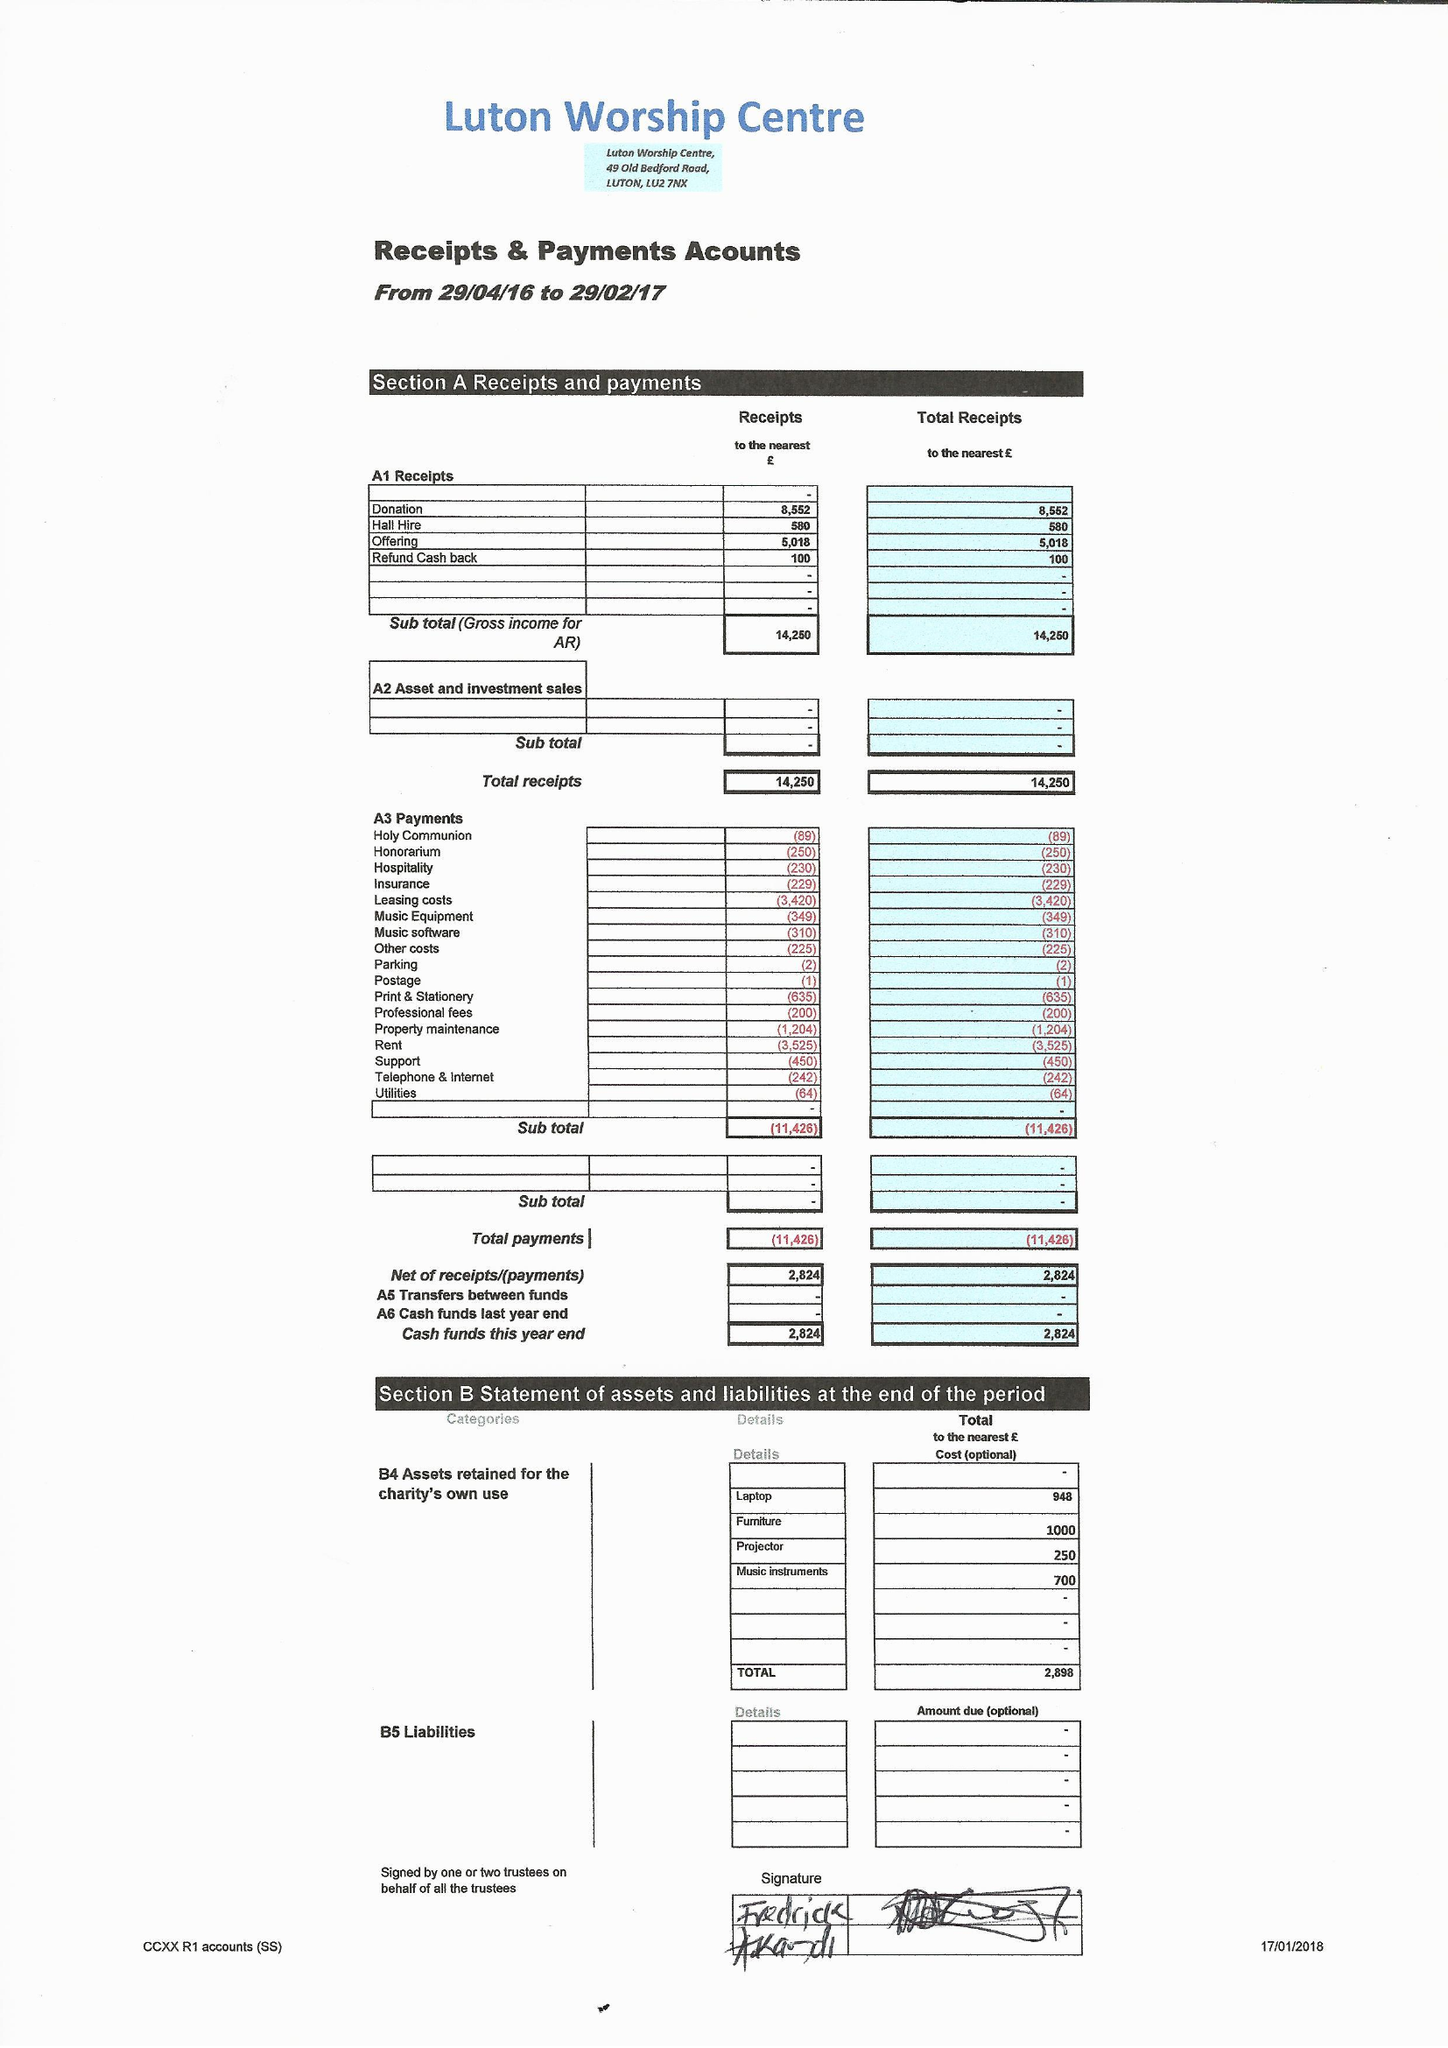What is the value for the address__post_town?
Answer the question using a single word or phrase. LUTON 